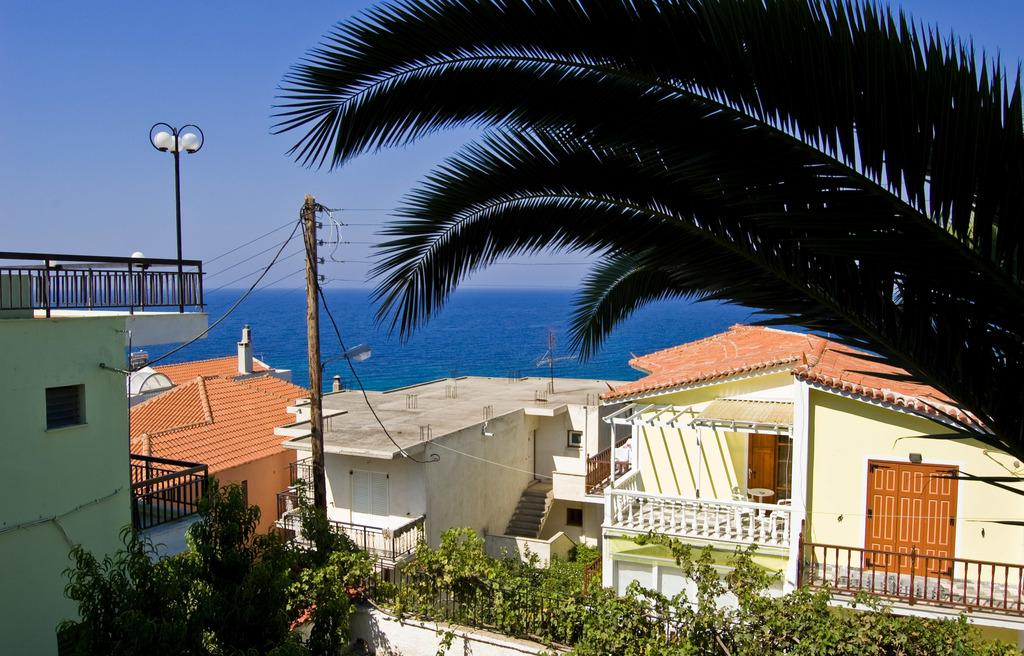What type of structures can be seen in the image? There are buildings in the image. What type of vegetation is present in the image? There are plants and trees in the image. What type of architectural feature can be seen in the image? There are iron grills in the image. What type of furniture is present in the image? There is a table and chairs in the image. What type of lighting is present in the image? There are lights in the image. What type of poles are visible in the image? There are poles in the image. What type of natural element is visible in the image? There is water and sky visible in the image. What type of trousers are hanging on the pole in the image? There are no trousers present in the image. What is the temper of the water in the image? The temper of the water cannot be determined from the image, as it does not provide information about the water's temperature. 